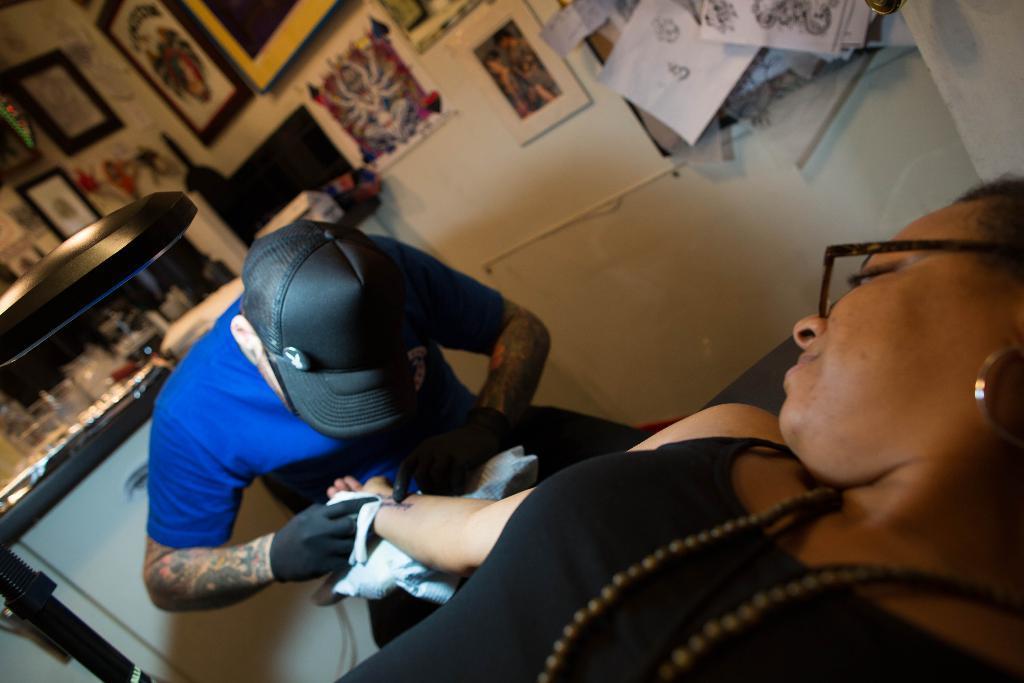Can you describe this image briefly? In the front of the image we can see a man and woman. A man is holding a woman hand. On that man hands there are tattoos. In the background we can see pictures, posters, cupboard, wall and things. At the left side of the image there is a lamp. 